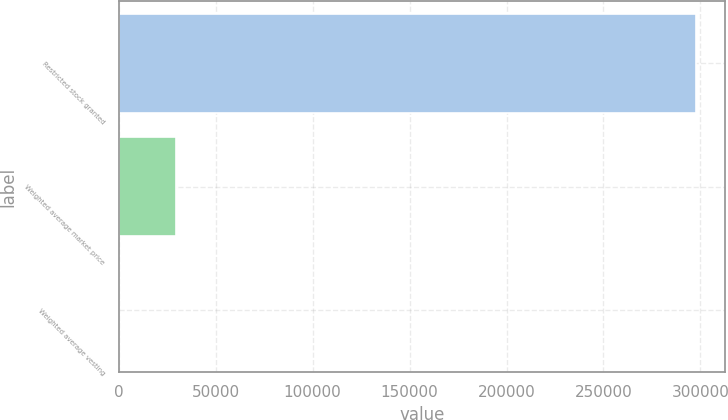Convert chart to OTSL. <chart><loc_0><loc_0><loc_500><loc_500><bar_chart><fcel>Restricted stock granted<fcel>Weighted average market price<fcel>Weighted average vesting<nl><fcel>297859<fcel>29787.9<fcel>2.27<nl></chart> 